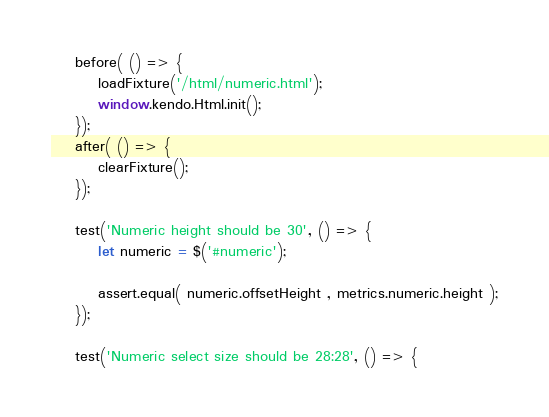Convert code to text. <code><loc_0><loc_0><loc_500><loc_500><_JavaScript_>    before( () => {
        loadFixture('/html/numeric.html');
        window.kendo.Html.init();
    });
    after( () => {
        clearFixture();
    });

    test('Numeric height should be 30', () => {
        let numeric = $('#numeric');

        assert.equal( numeric.offsetHeight , metrics.numeric.height );
    });

    test('Numeric select size should be 28:28', () => {</code> 